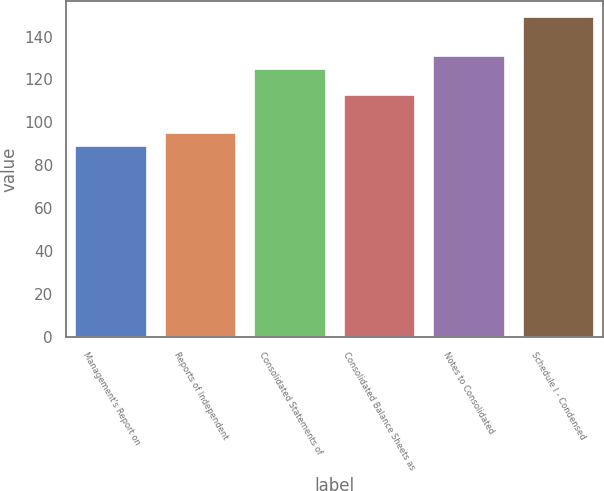Convert chart to OTSL. <chart><loc_0><loc_0><loc_500><loc_500><bar_chart><fcel>Management's Report on<fcel>Reports of Independent<fcel>Consolidated Statements of<fcel>Consolidated Balance Sheets as<fcel>Notes to Consolidated<fcel>Schedule I - Condensed<nl><fcel>89<fcel>95<fcel>125<fcel>113<fcel>131<fcel>149<nl></chart> 